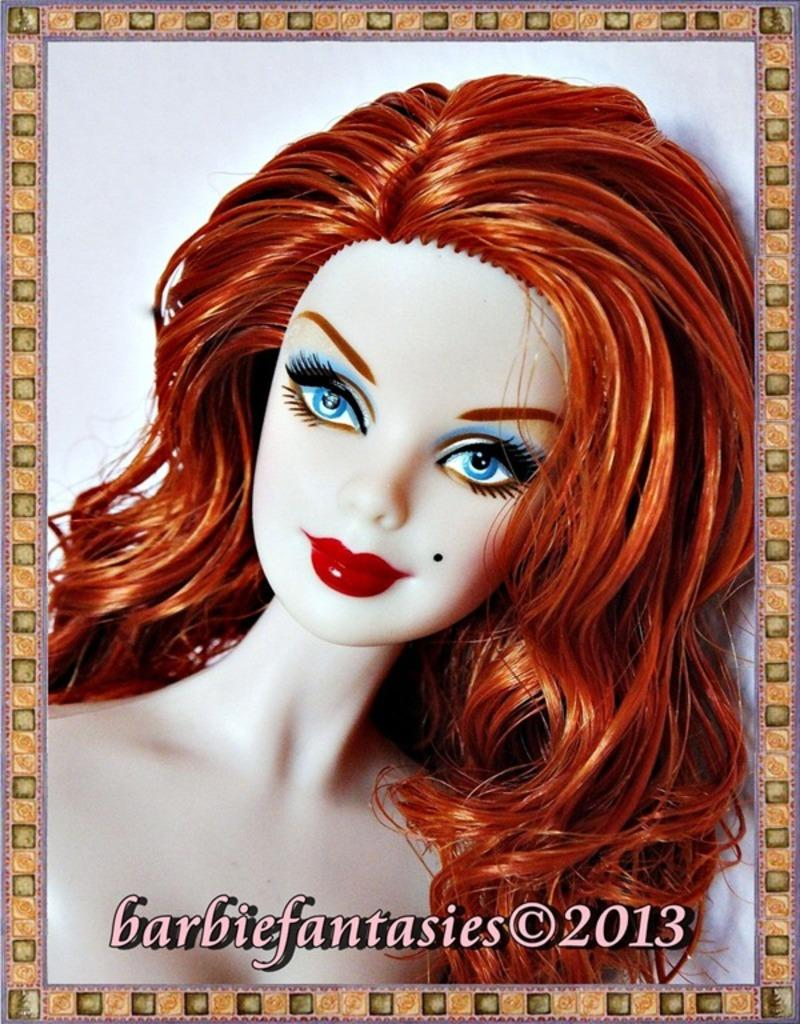What is the main object in the image? There is a painting photo frame in the image. What is depicted in the painting? The painting depicts a woman. What type of rake is being used to develop the woman's portrait in the image? There is no rake or development process depicted in the image; it is a static painting of a woman. 